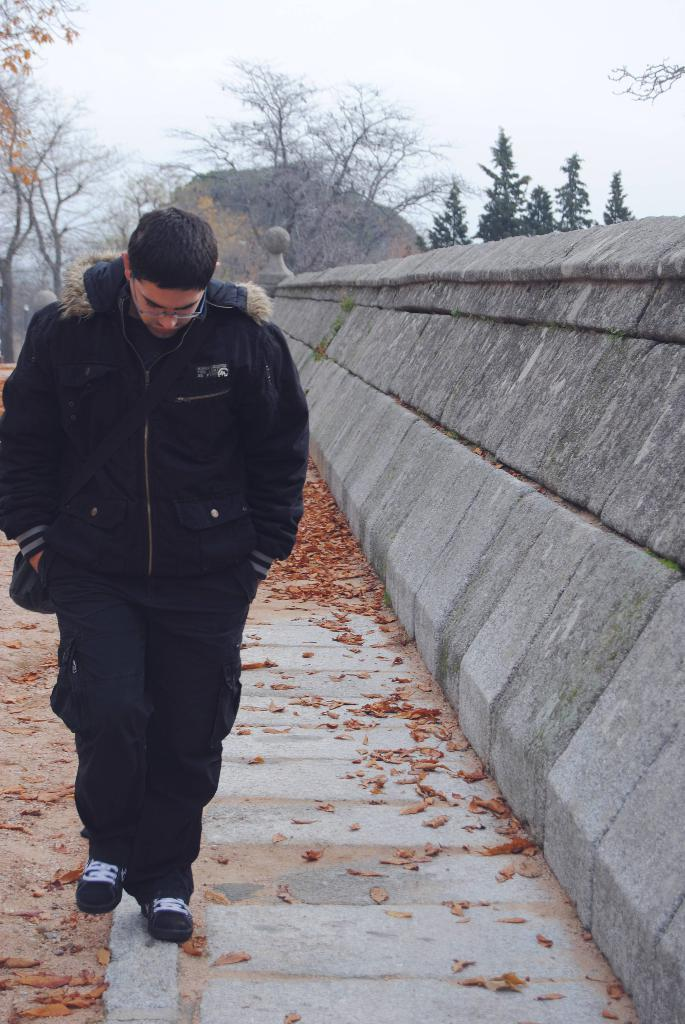What is the person in the image doing? There is a person walking in the image. What can be seen on the ground in the image? Dry leaves are present on the ground. What is located on the right side of the image? There is a wall on the right side of the image. What type of vegetation is visible in the image? There are trees at the back of the image. What is visible at the top of the image? The sky is visible at the top of the image. What type of jewel can be seen in the person's mouth in the image? There is no jewel visible in the person's mouth in the image. Is the person walking in the image during a rainstorm? The provided facts do not mention any rainstorm, so it cannot be determined from the image. 